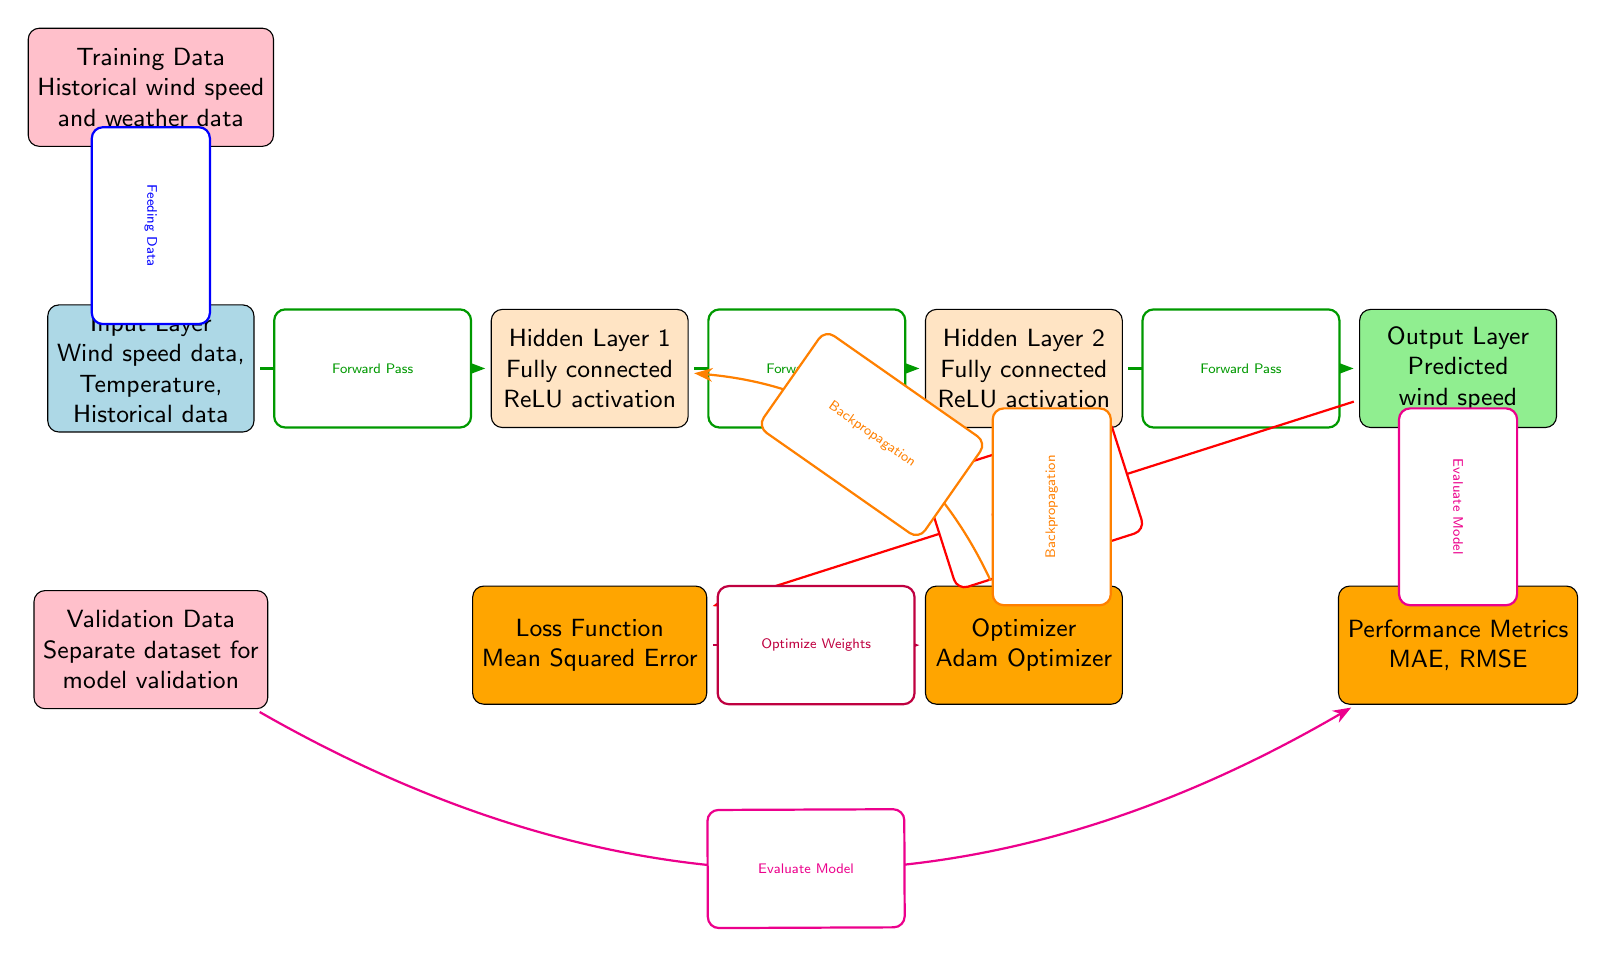What type of data is fed into the Input Layer? The Input Layer receives three types of data: Wind speed data, Temperature, and Historical data. This is directly indicated in the corresponding node of the diagram.
Answer: Wind speed data, Temperature, Historical data How many hidden layers are present in the architecture? The diagram clearly displays two hidden layers, labeled as Hidden Layer 1 and Hidden Layer 2. This can be seen in the arrangement of the nodes.
Answer: 2 What is the performance metric mentioned for evaluating the model? The Performance Metrics node lists MAE and RMSE as the metrics to evaluate the model’s performance. This is explicitly stated in the connected node.
Answer: MAE, RMSE What is the purpose of the Loss Function in this architecture? The Loss Function, which uses Mean Squared Error, plays a crucial role in measuring the difference between the predicted output and the actual values. Its function is indicated in its corresponding node in the diagram.
Answer: Mean Squared Error What is the process following the output layer? After the output layer, the diagram indicates that the next step is to calculate the loss, which directly connects the Output Layer to the Loss Function. This illustrates the flow of operations post-output.
Answer: Calculate Loss How is the connection between the optimizer and the first hidden layer established? The connection is established through backpropagation, which is indicated by the curved arrow going from the optimizer to the first hidden layer. This shows part of the optimization process after loss calculation.
Answer: Backpropagation Which optimizer is used in the architecture for weight optimization? In the diagram, the optimizer specified is the Adam Optimizer, which is directly noted in the Optimizer node below the second hidden layer.
Answer: Adam Optimizer What type of data is used for model validation? The Validation Data node notes “Separate dataset for model validation,” making it clear that this data is distinct from training data used to feed the input layer.
Answer: Separate dataset for model validation 